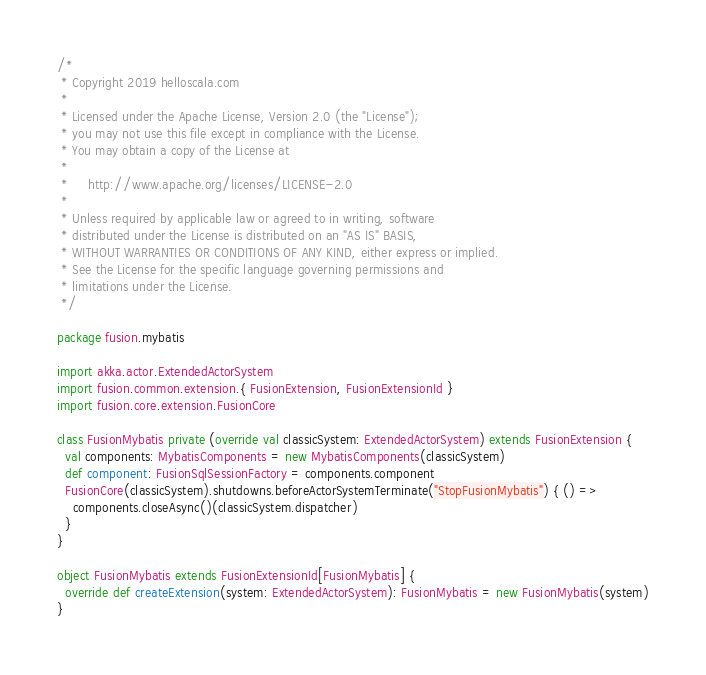<code> <loc_0><loc_0><loc_500><loc_500><_Scala_>/*
 * Copyright 2019 helloscala.com
 *
 * Licensed under the Apache License, Version 2.0 (the "License");
 * you may not use this file except in compliance with the License.
 * You may obtain a copy of the License at
 *
 *     http://www.apache.org/licenses/LICENSE-2.0
 *
 * Unless required by applicable law or agreed to in writing, software
 * distributed under the License is distributed on an "AS IS" BASIS,
 * WITHOUT WARRANTIES OR CONDITIONS OF ANY KIND, either express or implied.
 * See the License for the specific language governing permissions and
 * limitations under the License.
 */

package fusion.mybatis

import akka.actor.ExtendedActorSystem
import fusion.common.extension.{ FusionExtension, FusionExtensionId }
import fusion.core.extension.FusionCore

class FusionMybatis private (override val classicSystem: ExtendedActorSystem) extends FusionExtension {
  val components: MybatisComponents = new MybatisComponents(classicSystem)
  def component: FusionSqlSessionFactory = components.component
  FusionCore(classicSystem).shutdowns.beforeActorSystemTerminate("StopFusionMybatis") { () =>
    components.closeAsync()(classicSystem.dispatcher)
  }
}

object FusionMybatis extends FusionExtensionId[FusionMybatis] {
  override def createExtension(system: ExtendedActorSystem): FusionMybatis = new FusionMybatis(system)
}
</code> 